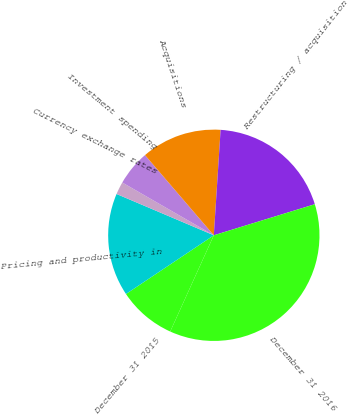<chart> <loc_0><loc_0><loc_500><loc_500><pie_chart><fcel>December 31 2015<fcel>Pricing and productivity in<fcel>Currency exchange rates<fcel>Investment spending<fcel>Acquisitions<fcel>Restructuring / acquisition<fcel>December 31 2016<nl><fcel>8.85%<fcel>15.77%<fcel>1.93%<fcel>5.39%<fcel>12.31%<fcel>19.23%<fcel>36.52%<nl></chart> 